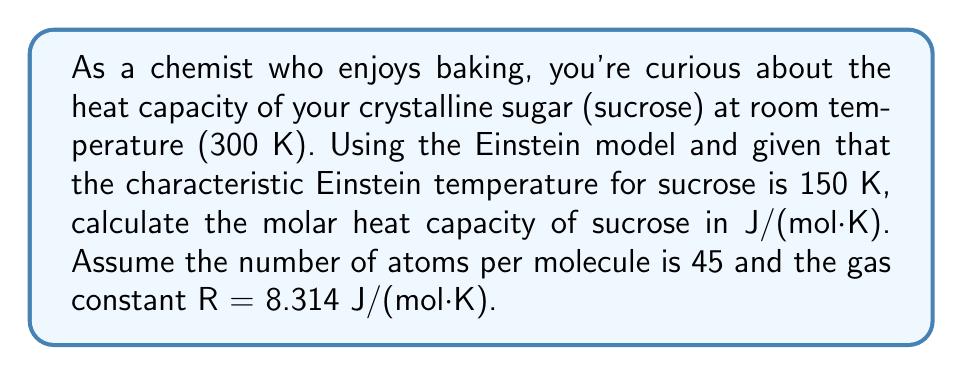Give your solution to this math problem. Let's approach this step-by-step using the Einstein model:

1) The Einstein model for the molar heat capacity is given by:

   $$C_V = 3NR \left(\frac{\theta_E}{T}\right)^2 \frac{e^{\theta_E/T}}{(e^{\theta_E/T}-1)^2}$$

   where N is the number of atoms per molecule, R is the gas constant, $\theta_E$ is the Einstein temperature, and T is the temperature.

2) We're given:
   N = 45 (atoms per sucrose molecule)
   R = 8.314 J/(mol·K)
   $\theta_E$ = 150 K
   T = 300 K

3) Let's substitute these values into the equation:

   $$C_V = 3 \cdot 45 \cdot 8.314 \left(\frac{150}{300}\right)^2 \frac{e^{150/300}}{(e^{150/300}-1)^2}$$

4) Simplify the fraction inside the parentheses:

   $$C_V = 1122.39 \cdot \left(\frac{1}{4}\right) \frac{e^{0.5}}{(e^{0.5}-1)^2}$$

5) Calculate $e^{0.5}$:
   $e^{0.5} \approx 1.6487$

6) Substitute this value:

   $$C_V = 280.5975 \cdot \frac{1.6487}{(1.6487-1)^2}$$

7) Simplify:

   $$C_V = 280.5975 \cdot \frac{1.6487}{0.4211} \approx 1100.95 \text{ J/(mol·K)}$$
Answer: 1101 J/(mol·K) 